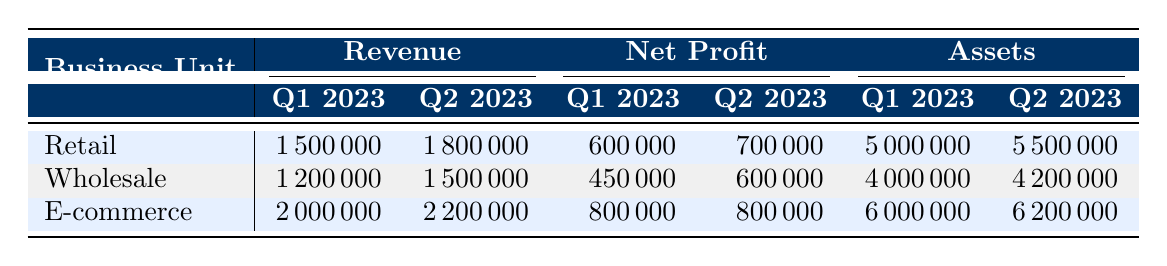What was the revenue for the Retail business unit in Q1 2023? The table directly lists the revenues for each business unit and quarter. For Retail in Q1 2023, the revenue is stated as 1,500,000.
Answer: 1,500,000 Which business unit had the highest net profit in Q2 2023? By comparing the net profits for each business unit in Q2 2023, Retail has a net profit of 700,000, Wholesale has 600,000, and E-commerce has 800,000. E-commerce has the highest net profit.
Answer: E-commerce What are the total assets for the Wholesale business unit across both quarters? To find the total assets for Wholesale, sum the assets for Q1 2023 (4,000,000) and Q2 2023 (4,200,000). The total is 4,000,000 + 4,200,000 = 8,200,000.
Answer: 8,200,000 Is the net profit for E-commerce in Q1 2023 greater than the expenses for Retail in Q2 2023? The net profit for E-commerce in Q1 2023 is 800,000 and the expenses for Retail in Q2 2023 are 1,100,000. Since 800,000 is less than 1,100,000, the statement is false.
Answer: No What is the difference in revenue between Retail and Wholesale in Q1 2023? For Q1 2023, Retail's revenue is 1,500,000 and Wholesale's revenue is 1,200,000. The difference is 1,500,000 - 1,200,000 = 300,000.
Answer: 300,000 How much did E-commerce's net profit change from Q1 2023 to Q2 2023? The net profit for E-commerce remained the same at 800,000 in both quarters. The change is 800,000 - 800,000 = 0.
Answer: 0 Which business unit experienced the largest increase in revenue from Q1 2023 to Q2 2023? Retail's revenue increased by 300,000, Wholesale's increased by 300,000, and E-commerce's increased by 200,000. The increase is the same for Retail and Wholesale, thus both experienced the largest increase.
Answer: Retail and Wholesale What was the ratio of liabilities to assets for the E-commerce unit in Q2 2023? For Q2 2023, E-commerce has liabilities of 2,600,000 and assets of 6,200,000. The ratio is calculated as 2,600,000 / 6,200,000 = 0.419.
Answer: 0.419 